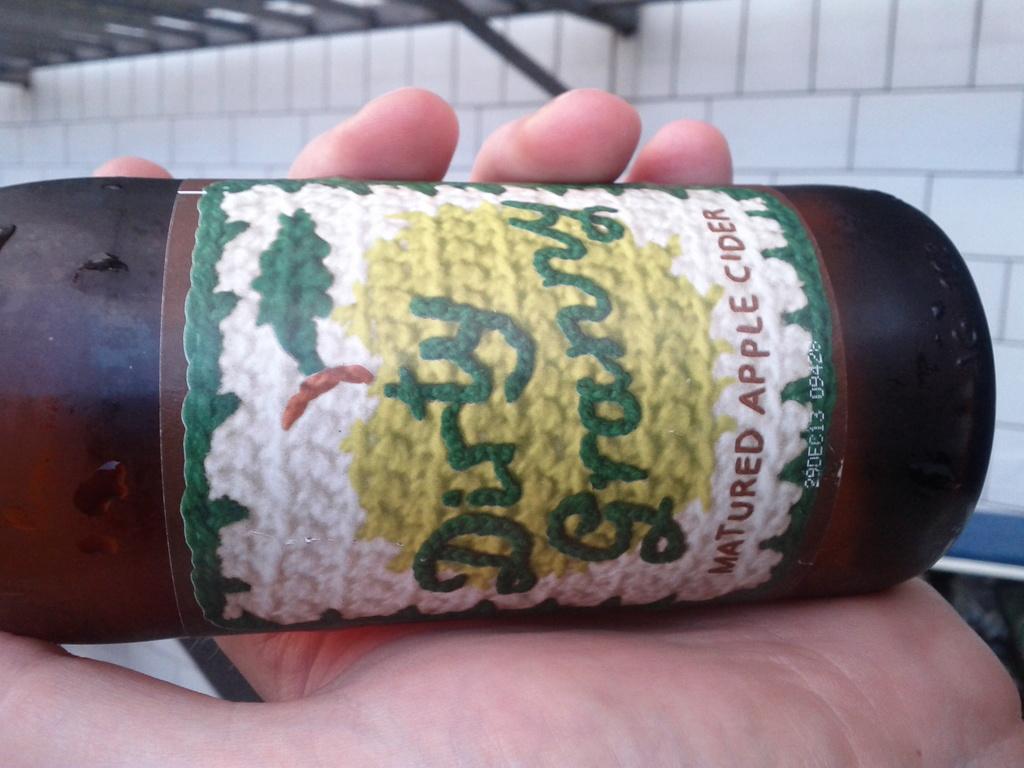What adjective is mentioned before the word granny on the label?
Ensure brevity in your answer.  Dirty. What type of beverage is this?
Make the answer very short. Matured apple cider. 